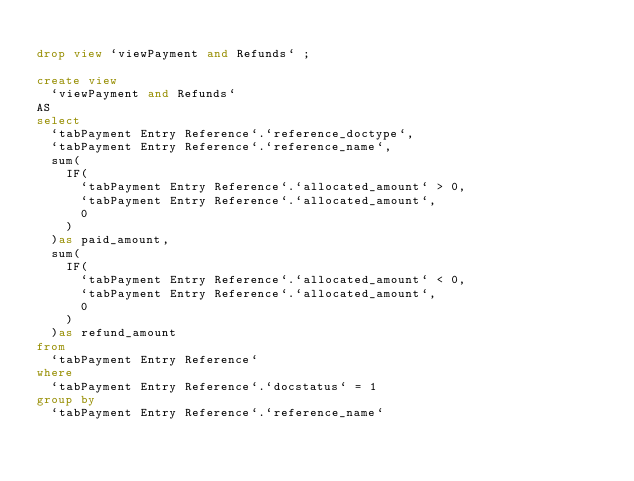Convert code to text. <code><loc_0><loc_0><loc_500><loc_500><_SQL_>
drop view `viewPayment and Refunds` ;

create view 
	`viewPayment and Refunds`
AS 
select 
	`tabPayment Entry Reference`.`reference_doctype`,
	`tabPayment Entry Reference`.`reference_name`,
	sum(
		IF(
			`tabPayment Entry Reference`.`allocated_amount` > 0,
			`tabPayment Entry Reference`.`allocated_amount`,
			0 
		)
	)as paid_amount,
	sum(
		IF(
			`tabPayment Entry Reference`.`allocated_amount` < 0,
			`tabPayment Entry Reference`.`allocated_amount`,
			0 
		)
	)as refund_amount
from 
	`tabPayment Entry Reference` 
where 
	`tabPayment Entry Reference`.`docstatus` = 1
group by 
	`tabPayment Entry Reference`.`reference_name`</code> 